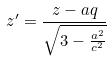<formula> <loc_0><loc_0><loc_500><loc_500>z ^ { \prime } = \frac { z - a q } { \sqrt { 3 - \frac { a ^ { 2 } } { c ^ { 2 } } } }</formula> 